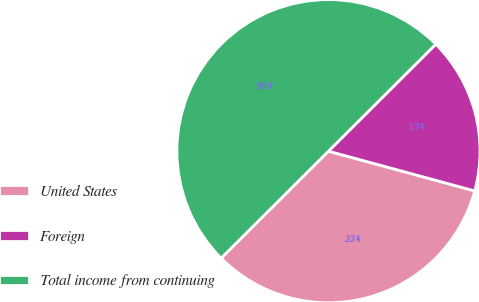<chart> <loc_0><loc_0><loc_500><loc_500><pie_chart><fcel>United States<fcel>Foreign<fcel>Total income from continuing<nl><fcel>33.3%<fcel>16.7%<fcel>50.0%<nl></chart> 